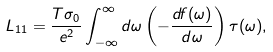<formula> <loc_0><loc_0><loc_500><loc_500>L _ { 1 1 } = \frac { T \sigma _ { 0 } } { e ^ { 2 } } \int _ { - \infty } ^ { \infty } d \omega \left ( - \frac { d f ( \omega ) } { d \omega } \right ) \tau ( \omega ) ,</formula> 